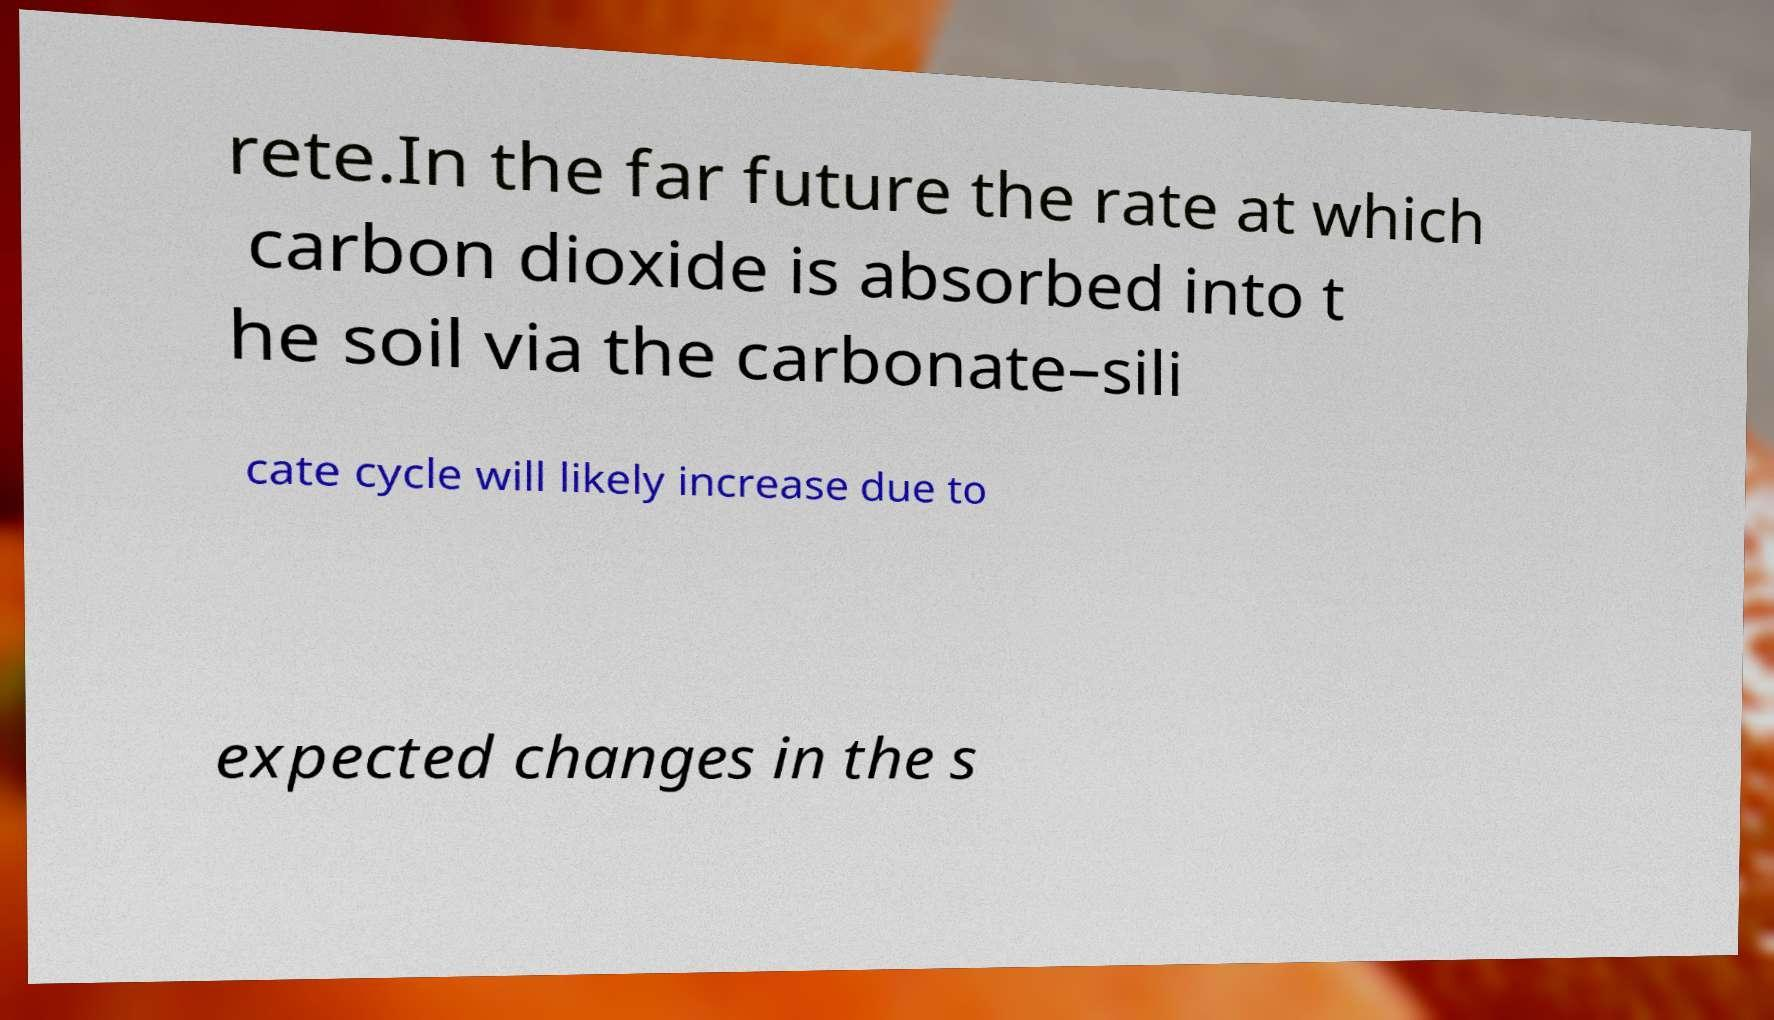Please identify and transcribe the text found in this image. rete.In the far future the rate at which carbon dioxide is absorbed into t he soil via the carbonate–sili cate cycle will likely increase due to expected changes in the s 